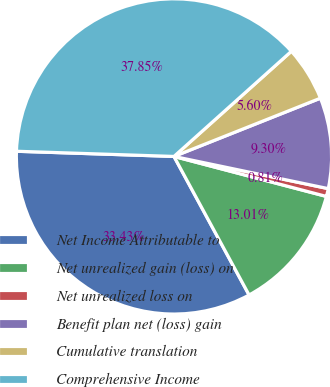<chart> <loc_0><loc_0><loc_500><loc_500><pie_chart><fcel>Net Income Attributable to<fcel>Net unrealized gain (loss) on<fcel>Net unrealized loss on<fcel>Benefit plan net (loss) gain<fcel>Cumulative translation<fcel>Comprehensive Income<nl><fcel>33.43%<fcel>13.01%<fcel>0.81%<fcel>9.3%<fcel>5.6%<fcel>37.85%<nl></chart> 